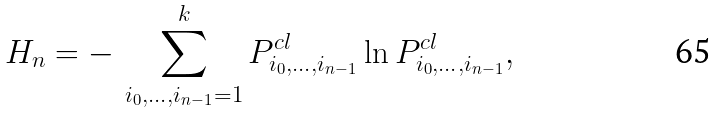Convert formula to latex. <formula><loc_0><loc_0><loc_500><loc_500>H _ { n } = - \, \sum _ { i _ { 0 } , \dots , i _ { n - 1 } = 1 } ^ { k } P ^ { c l } _ { i _ { 0 } , \dots , i _ { n - 1 } } \ln P ^ { c l } _ { i _ { 0 } , \dots , i _ { n - 1 } } ,</formula> 